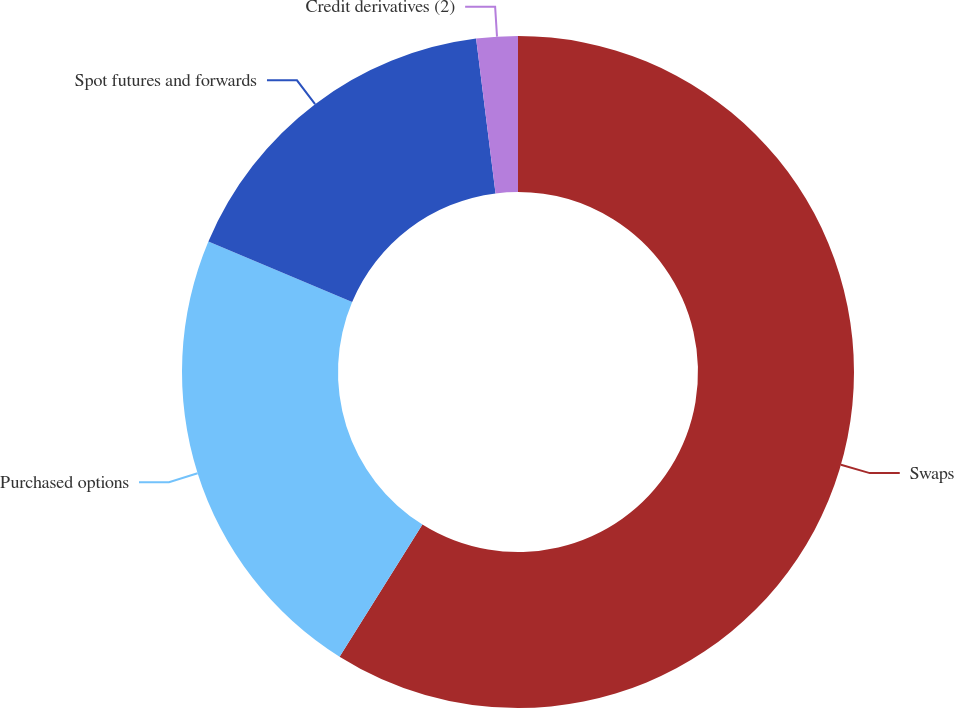<chart> <loc_0><loc_0><loc_500><loc_500><pie_chart><fcel>Swaps<fcel>Purchased options<fcel>Spot futures and forwards<fcel>Credit derivatives (2)<nl><fcel>58.91%<fcel>22.44%<fcel>16.66%<fcel>1.99%<nl></chart> 